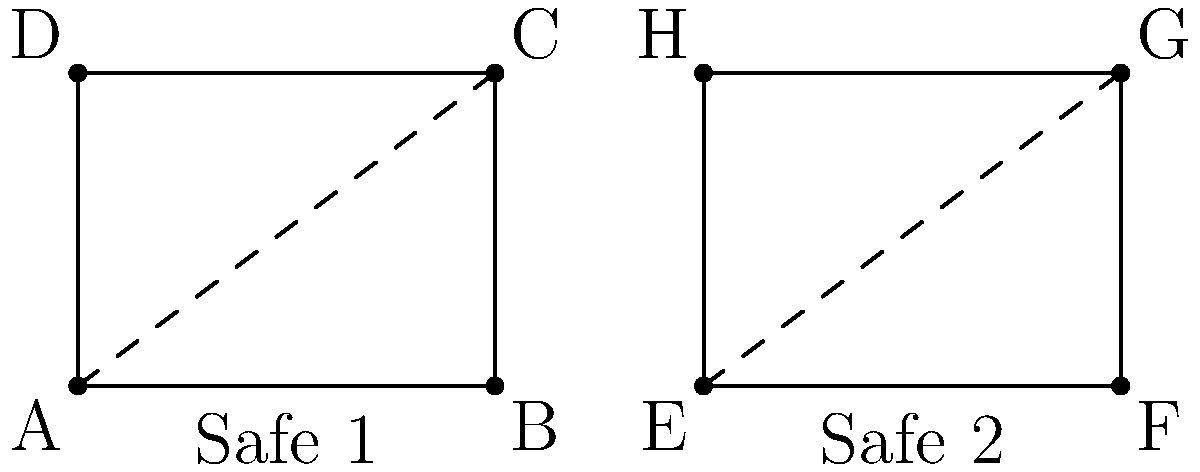Two safe designs are shown above. If Safe 1 has a perimeter of 14 units and Safe 2 has a perimeter of 20 units, what is the ratio of the area of Safe 2 to the area of Safe 1? Let's approach this step-by-step:

1) First, we need to determine if the safes are similar. They appear to be rectangles with the same shape, so they are likely similar.

2) For similar polygons, the ratio of their areas is equal to the square of the ratio of their corresponding sides.

3) We can use the perimeters to find the ratio of corresponding sides:
   Let x be the scale factor from Safe 1 to Safe 2.
   Then, $20 = 14x$
   $x = \frac{20}{14} = \frac{10}{7}$

4) Now, we can use this to find the ratio of areas:
   Area ratio = $x^2 = (\frac{10}{7})^2 = \frac{100}{49}$

5) This means the area of Safe 2 is $\frac{100}{49}$ times the area of Safe 1.

6) We can simplify this fraction to get our final answer.
Answer: $\frac{100}{49}$ 